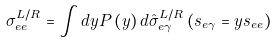Convert formula to latex. <formula><loc_0><loc_0><loc_500><loc_500>\sigma _ { e e } ^ { L / R } = \int d y P \left ( y \right ) d \hat { \sigma } _ { e \gamma } ^ { L / R } \left ( s _ { e \gamma } = y s _ { e e } \right )</formula> 